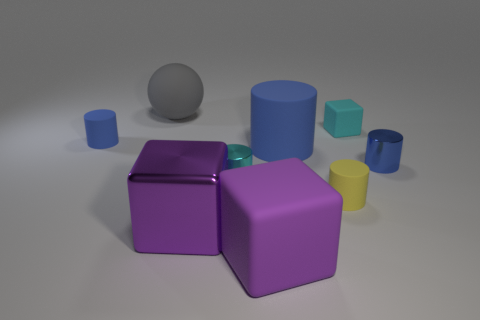Are the yellow object and the gray thing made of the same material?
Provide a short and direct response. Yes. What number of other objects are there of the same size as the gray thing?
Offer a very short reply. 3. What is the size of the purple cube that is right of the tiny cyan thing that is in front of the tiny matte block?
Your response must be concise. Large. What is the color of the metallic cylinder that is to the left of the matte block behind the tiny rubber cylinder that is left of the big cylinder?
Make the answer very short. Cyan. There is a cylinder that is in front of the large blue cylinder and to the left of the small yellow cylinder; what size is it?
Your answer should be compact. Small. What number of other objects are the same shape as the large metallic object?
Your answer should be compact. 2. What number of spheres are tiny metallic things or metallic things?
Ensure brevity in your answer.  0. There is a large purple object to the left of the cyan object that is in front of the tiny cyan block; is there a large cube that is in front of it?
Your answer should be very brief. Yes. What is the color of the other metallic object that is the same shape as the blue metal object?
Provide a succinct answer. Cyan. What number of cyan objects are shiny cubes or cubes?
Make the answer very short. 1. 